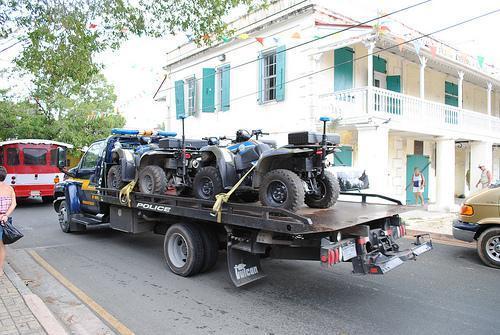How many four wheelers are on the truck?
Give a very brief answer. 2. 